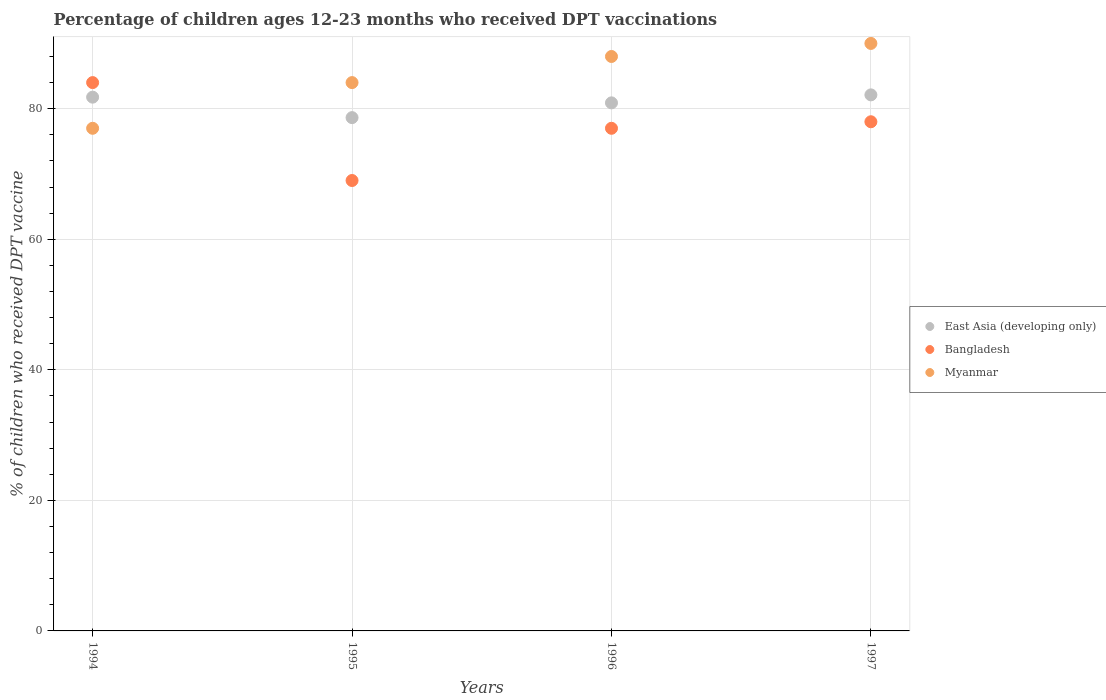How many different coloured dotlines are there?
Your answer should be very brief. 3. Is the number of dotlines equal to the number of legend labels?
Keep it short and to the point. Yes. What is the percentage of children who received DPT vaccination in East Asia (developing only) in 1994?
Keep it short and to the point. 81.77. Across all years, what is the maximum percentage of children who received DPT vaccination in Bangladesh?
Provide a succinct answer. 84. Across all years, what is the minimum percentage of children who received DPT vaccination in Myanmar?
Your response must be concise. 77. In which year was the percentage of children who received DPT vaccination in East Asia (developing only) maximum?
Your response must be concise. 1997. What is the total percentage of children who received DPT vaccination in Myanmar in the graph?
Keep it short and to the point. 339. What is the difference between the percentage of children who received DPT vaccination in East Asia (developing only) in 1994 and that in 1996?
Provide a succinct answer. 0.87. What is the average percentage of children who received DPT vaccination in Bangladesh per year?
Make the answer very short. 77. In the year 1997, what is the difference between the percentage of children who received DPT vaccination in Bangladesh and percentage of children who received DPT vaccination in East Asia (developing only)?
Offer a very short reply. -4.12. In how many years, is the percentage of children who received DPT vaccination in Myanmar greater than 32 %?
Keep it short and to the point. 4. What is the ratio of the percentage of children who received DPT vaccination in Bangladesh in 1994 to that in 1996?
Your response must be concise. 1.09. Is the percentage of children who received DPT vaccination in East Asia (developing only) in 1994 less than that in 1995?
Provide a short and direct response. No. Is the difference between the percentage of children who received DPT vaccination in Bangladesh in 1994 and 1997 greater than the difference between the percentage of children who received DPT vaccination in East Asia (developing only) in 1994 and 1997?
Make the answer very short. Yes. What is the difference between the highest and the second highest percentage of children who received DPT vaccination in Bangladesh?
Provide a short and direct response. 6. What is the difference between the highest and the lowest percentage of children who received DPT vaccination in Bangladesh?
Give a very brief answer. 15. In how many years, is the percentage of children who received DPT vaccination in Myanmar greater than the average percentage of children who received DPT vaccination in Myanmar taken over all years?
Make the answer very short. 2. Is it the case that in every year, the sum of the percentage of children who received DPT vaccination in Bangladesh and percentage of children who received DPT vaccination in East Asia (developing only)  is greater than the percentage of children who received DPT vaccination in Myanmar?
Ensure brevity in your answer.  Yes. Is the percentage of children who received DPT vaccination in East Asia (developing only) strictly greater than the percentage of children who received DPT vaccination in Myanmar over the years?
Offer a terse response. No. How many years are there in the graph?
Offer a terse response. 4. Are the values on the major ticks of Y-axis written in scientific E-notation?
Give a very brief answer. No. Does the graph contain any zero values?
Offer a very short reply. No. Where does the legend appear in the graph?
Provide a succinct answer. Center right. What is the title of the graph?
Provide a short and direct response. Percentage of children ages 12-23 months who received DPT vaccinations. What is the label or title of the Y-axis?
Make the answer very short. % of children who received DPT vaccine. What is the % of children who received DPT vaccine in East Asia (developing only) in 1994?
Make the answer very short. 81.77. What is the % of children who received DPT vaccine of Bangladesh in 1994?
Your response must be concise. 84. What is the % of children who received DPT vaccine of Myanmar in 1994?
Keep it short and to the point. 77. What is the % of children who received DPT vaccine of East Asia (developing only) in 1995?
Your answer should be compact. 78.63. What is the % of children who received DPT vaccine in Bangladesh in 1995?
Your answer should be very brief. 69. What is the % of children who received DPT vaccine of Myanmar in 1995?
Provide a short and direct response. 84. What is the % of children who received DPT vaccine of East Asia (developing only) in 1996?
Ensure brevity in your answer.  80.89. What is the % of children who received DPT vaccine of East Asia (developing only) in 1997?
Provide a short and direct response. 82.12. What is the % of children who received DPT vaccine of Myanmar in 1997?
Your answer should be very brief. 90. Across all years, what is the maximum % of children who received DPT vaccine in East Asia (developing only)?
Offer a terse response. 82.12. Across all years, what is the maximum % of children who received DPT vaccine of Bangladesh?
Your answer should be very brief. 84. Across all years, what is the maximum % of children who received DPT vaccine in Myanmar?
Your answer should be very brief. 90. Across all years, what is the minimum % of children who received DPT vaccine of East Asia (developing only)?
Keep it short and to the point. 78.63. What is the total % of children who received DPT vaccine in East Asia (developing only) in the graph?
Offer a terse response. 323.42. What is the total % of children who received DPT vaccine of Bangladesh in the graph?
Provide a succinct answer. 308. What is the total % of children who received DPT vaccine in Myanmar in the graph?
Your response must be concise. 339. What is the difference between the % of children who received DPT vaccine of East Asia (developing only) in 1994 and that in 1995?
Offer a terse response. 3.14. What is the difference between the % of children who received DPT vaccine of Myanmar in 1994 and that in 1995?
Offer a very short reply. -7. What is the difference between the % of children who received DPT vaccine in East Asia (developing only) in 1994 and that in 1996?
Give a very brief answer. 0.87. What is the difference between the % of children who received DPT vaccine in Myanmar in 1994 and that in 1996?
Ensure brevity in your answer.  -11. What is the difference between the % of children who received DPT vaccine of East Asia (developing only) in 1994 and that in 1997?
Keep it short and to the point. -0.35. What is the difference between the % of children who received DPT vaccine in Bangladesh in 1994 and that in 1997?
Give a very brief answer. 6. What is the difference between the % of children who received DPT vaccine in East Asia (developing only) in 1995 and that in 1996?
Provide a succinct answer. -2.26. What is the difference between the % of children who received DPT vaccine in East Asia (developing only) in 1995 and that in 1997?
Ensure brevity in your answer.  -3.49. What is the difference between the % of children who received DPT vaccine in East Asia (developing only) in 1996 and that in 1997?
Offer a very short reply. -1.22. What is the difference between the % of children who received DPT vaccine in East Asia (developing only) in 1994 and the % of children who received DPT vaccine in Bangladesh in 1995?
Your response must be concise. 12.77. What is the difference between the % of children who received DPT vaccine of East Asia (developing only) in 1994 and the % of children who received DPT vaccine of Myanmar in 1995?
Offer a very short reply. -2.23. What is the difference between the % of children who received DPT vaccine of East Asia (developing only) in 1994 and the % of children who received DPT vaccine of Bangladesh in 1996?
Your answer should be very brief. 4.77. What is the difference between the % of children who received DPT vaccine in East Asia (developing only) in 1994 and the % of children who received DPT vaccine in Myanmar in 1996?
Offer a very short reply. -6.23. What is the difference between the % of children who received DPT vaccine in East Asia (developing only) in 1994 and the % of children who received DPT vaccine in Bangladesh in 1997?
Offer a terse response. 3.77. What is the difference between the % of children who received DPT vaccine in East Asia (developing only) in 1994 and the % of children who received DPT vaccine in Myanmar in 1997?
Offer a very short reply. -8.23. What is the difference between the % of children who received DPT vaccine of Bangladesh in 1994 and the % of children who received DPT vaccine of Myanmar in 1997?
Your answer should be compact. -6. What is the difference between the % of children who received DPT vaccine in East Asia (developing only) in 1995 and the % of children who received DPT vaccine in Bangladesh in 1996?
Keep it short and to the point. 1.63. What is the difference between the % of children who received DPT vaccine in East Asia (developing only) in 1995 and the % of children who received DPT vaccine in Myanmar in 1996?
Provide a short and direct response. -9.37. What is the difference between the % of children who received DPT vaccine in East Asia (developing only) in 1995 and the % of children who received DPT vaccine in Bangladesh in 1997?
Ensure brevity in your answer.  0.63. What is the difference between the % of children who received DPT vaccine of East Asia (developing only) in 1995 and the % of children who received DPT vaccine of Myanmar in 1997?
Offer a very short reply. -11.37. What is the difference between the % of children who received DPT vaccine in Bangladesh in 1995 and the % of children who received DPT vaccine in Myanmar in 1997?
Keep it short and to the point. -21. What is the difference between the % of children who received DPT vaccine in East Asia (developing only) in 1996 and the % of children who received DPT vaccine in Bangladesh in 1997?
Your answer should be compact. 2.89. What is the difference between the % of children who received DPT vaccine of East Asia (developing only) in 1996 and the % of children who received DPT vaccine of Myanmar in 1997?
Give a very brief answer. -9.11. What is the difference between the % of children who received DPT vaccine of Bangladesh in 1996 and the % of children who received DPT vaccine of Myanmar in 1997?
Offer a very short reply. -13. What is the average % of children who received DPT vaccine of East Asia (developing only) per year?
Your response must be concise. 80.85. What is the average % of children who received DPT vaccine of Bangladesh per year?
Your response must be concise. 77. What is the average % of children who received DPT vaccine in Myanmar per year?
Your response must be concise. 84.75. In the year 1994, what is the difference between the % of children who received DPT vaccine in East Asia (developing only) and % of children who received DPT vaccine in Bangladesh?
Your answer should be compact. -2.23. In the year 1994, what is the difference between the % of children who received DPT vaccine of East Asia (developing only) and % of children who received DPT vaccine of Myanmar?
Give a very brief answer. 4.77. In the year 1994, what is the difference between the % of children who received DPT vaccine of Bangladesh and % of children who received DPT vaccine of Myanmar?
Give a very brief answer. 7. In the year 1995, what is the difference between the % of children who received DPT vaccine of East Asia (developing only) and % of children who received DPT vaccine of Bangladesh?
Ensure brevity in your answer.  9.63. In the year 1995, what is the difference between the % of children who received DPT vaccine of East Asia (developing only) and % of children who received DPT vaccine of Myanmar?
Offer a very short reply. -5.37. In the year 1995, what is the difference between the % of children who received DPT vaccine in Bangladesh and % of children who received DPT vaccine in Myanmar?
Offer a very short reply. -15. In the year 1996, what is the difference between the % of children who received DPT vaccine in East Asia (developing only) and % of children who received DPT vaccine in Bangladesh?
Your response must be concise. 3.89. In the year 1996, what is the difference between the % of children who received DPT vaccine of East Asia (developing only) and % of children who received DPT vaccine of Myanmar?
Provide a succinct answer. -7.11. In the year 1997, what is the difference between the % of children who received DPT vaccine of East Asia (developing only) and % of children who received DPT vaccine of Bangladesh?
Provide a short and direct response. 4.12. In the year 1997, what is the difference between the % of children who received DPT vaccine of East Asia (developing only) and % of children who received DPT vaccine of Myanmar?
Provide a succinct answer. -7.88. What is the ratio of the % of children who received DPT vaccine of East Asia (developing only) in 1994 to that in 1995?
Your answer should be very brief. 1.04. What is the ratio of the % of children who received DPT vaccine of Bangladesh in 1994 to that in 1995?
Provide a short and direct response. 1.22. What is the ratio of the % of children who received DPT vaccine in East Asia (developing only) in 1994 to that in 1996?
Make the answer very short. 1.01. What is the ratio of the % of children who received DPT vaccine of Myanmar in 1994 to that in 1997?
Your response must be concise. 0.86. What is the ratio of the % of children who received DPT vaccine in Bangladesh in 1995 to that in 1996?
Keep it short and to the point. 0.9. What is the ratio of the % of children who received DPT vaccine in Myanmar in 1995 to that in 1996?
Your response must be concise. 0.95. What is the ratio of the % of children who received DPT vaccine of East Asia (developing only) in 1995 to that in 1997?
Provide a succinct answer. 0.96. What is the ratio of the % of children who received DPT vaccine in Bangladesh in 1995 to that in 1997?
Your answer should be compact. 0.88. What is the ratio of the % of children who received DPT vaccine of East Asia (developing only) in 1996 to that in 1997?
Give a very brief answer. 0.99. What is the ratio of the % of children who received DPT vaccine in Bangladesh in 1996 to that in 1997?
Your answer should be compact. 0.99. What is the ratio of the % of children who received DPT vaccine of Myanmar in 1996 to that in 1997?
Your answer should be very brief. 0.98. What is the difference between the highest and the second highest % of children who received DPT vaccine of East Asia (developing only)?
Offer a very short reply. 0.35. What is the difference between the highest and the second highest % of children who received DPT vaccine in Myanmar?
Ensure brevity in your answer.  2. What is the difference between the highest and the lowest % of children who received DPT vaccine in East Asia (developing only)?
Ensure brevity in your answer.  3.49. What is the difference between the highest and the lowest % of children who received DPT vaccine of Bangladesh?
Your answer should be very brief. 15. 